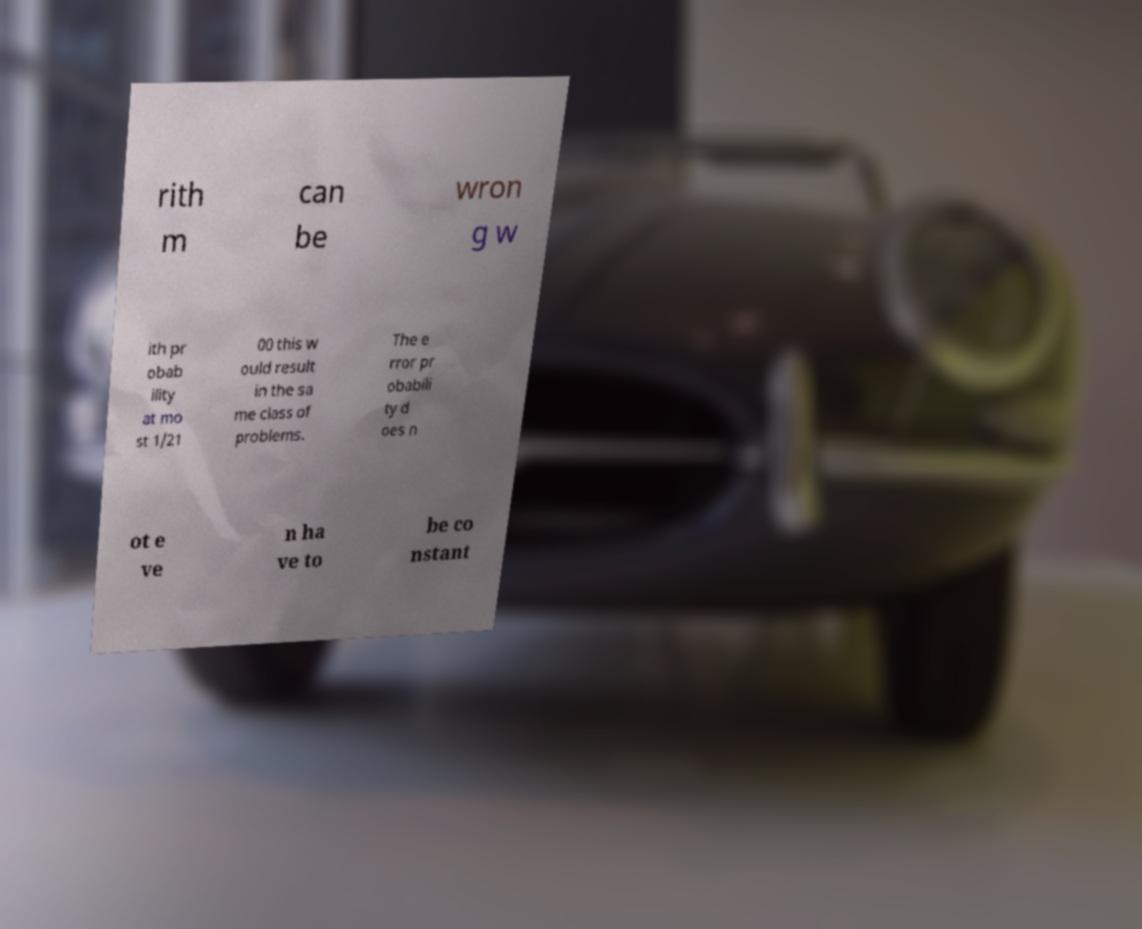I need the written content from this picture converted into text. Can you do that? rith m can be wron g w ith pr obab ility at mo st 1/21 00 this w ould result in the sa me class of problems. The e rror pr obabili ty d oes n ot e ve n ha ve to be co nstant 